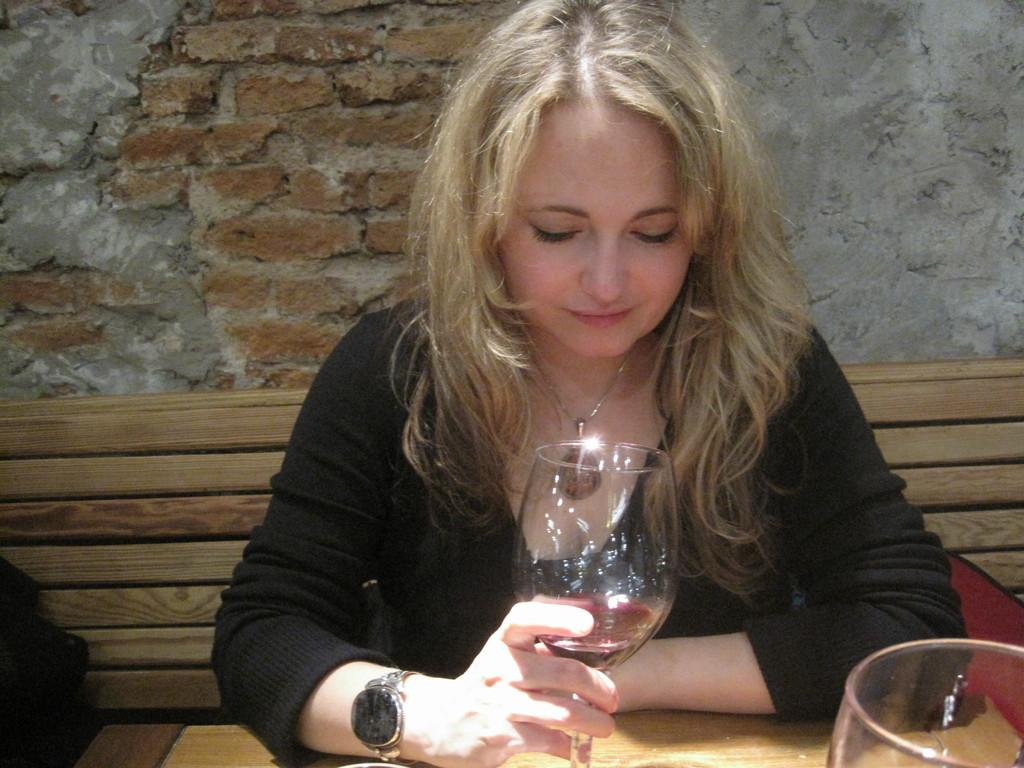Who is present in the image? There is a woman in the image. What is the woman holding in the image? The woman is holding a glass. What is the primary object in the image that the woman is interacting with? There is a table in the image, and the woman is holding a glass on it. What can be seen in the background of the image? There is a wall in the background of the image. What type of sticks are being used in the competition in the image? There is no competition or sticks present in the image; it features a woman holding a glass on a table with a wall in the background. 